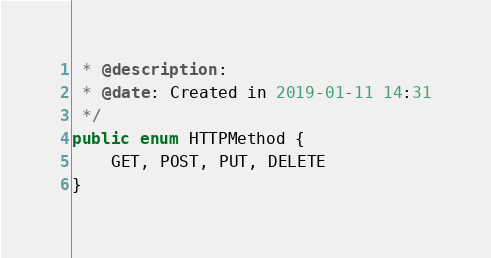<code> <loc_0><loc_0><loc_500><loc_500><_Java_> * @description:
 * @date: Created in 2019-01-11 14:31
 */
public enum HTTPMethod {
    GET, POST, PUT, DELETE
}
</code> 